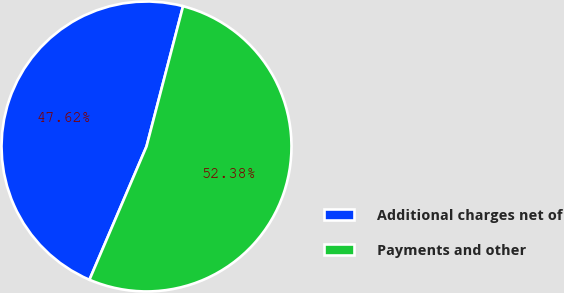<chart> <loc_0><loc_0><loc_500><loc_500><pie_chart><fcel>Additional charges net of<fcel>Payments and other<nl><fcel>47.62%<fcel>52.38%<nl></chart> 